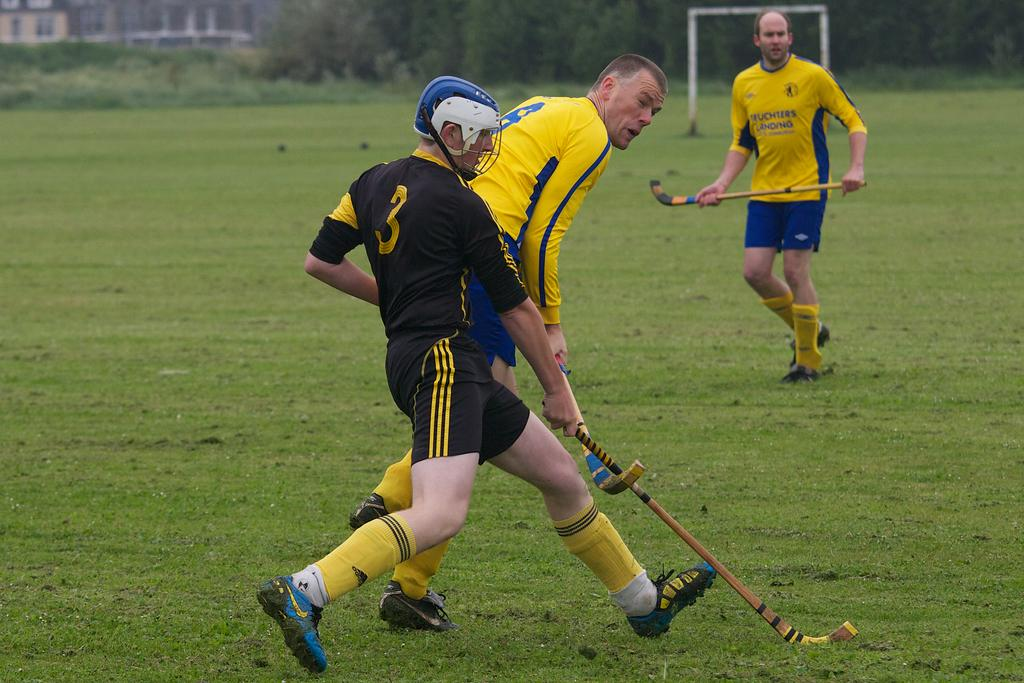<image>
Present a compact description of the photo's key features. guy wearing black with #3 jersey  and two others with yellow and blue on field 